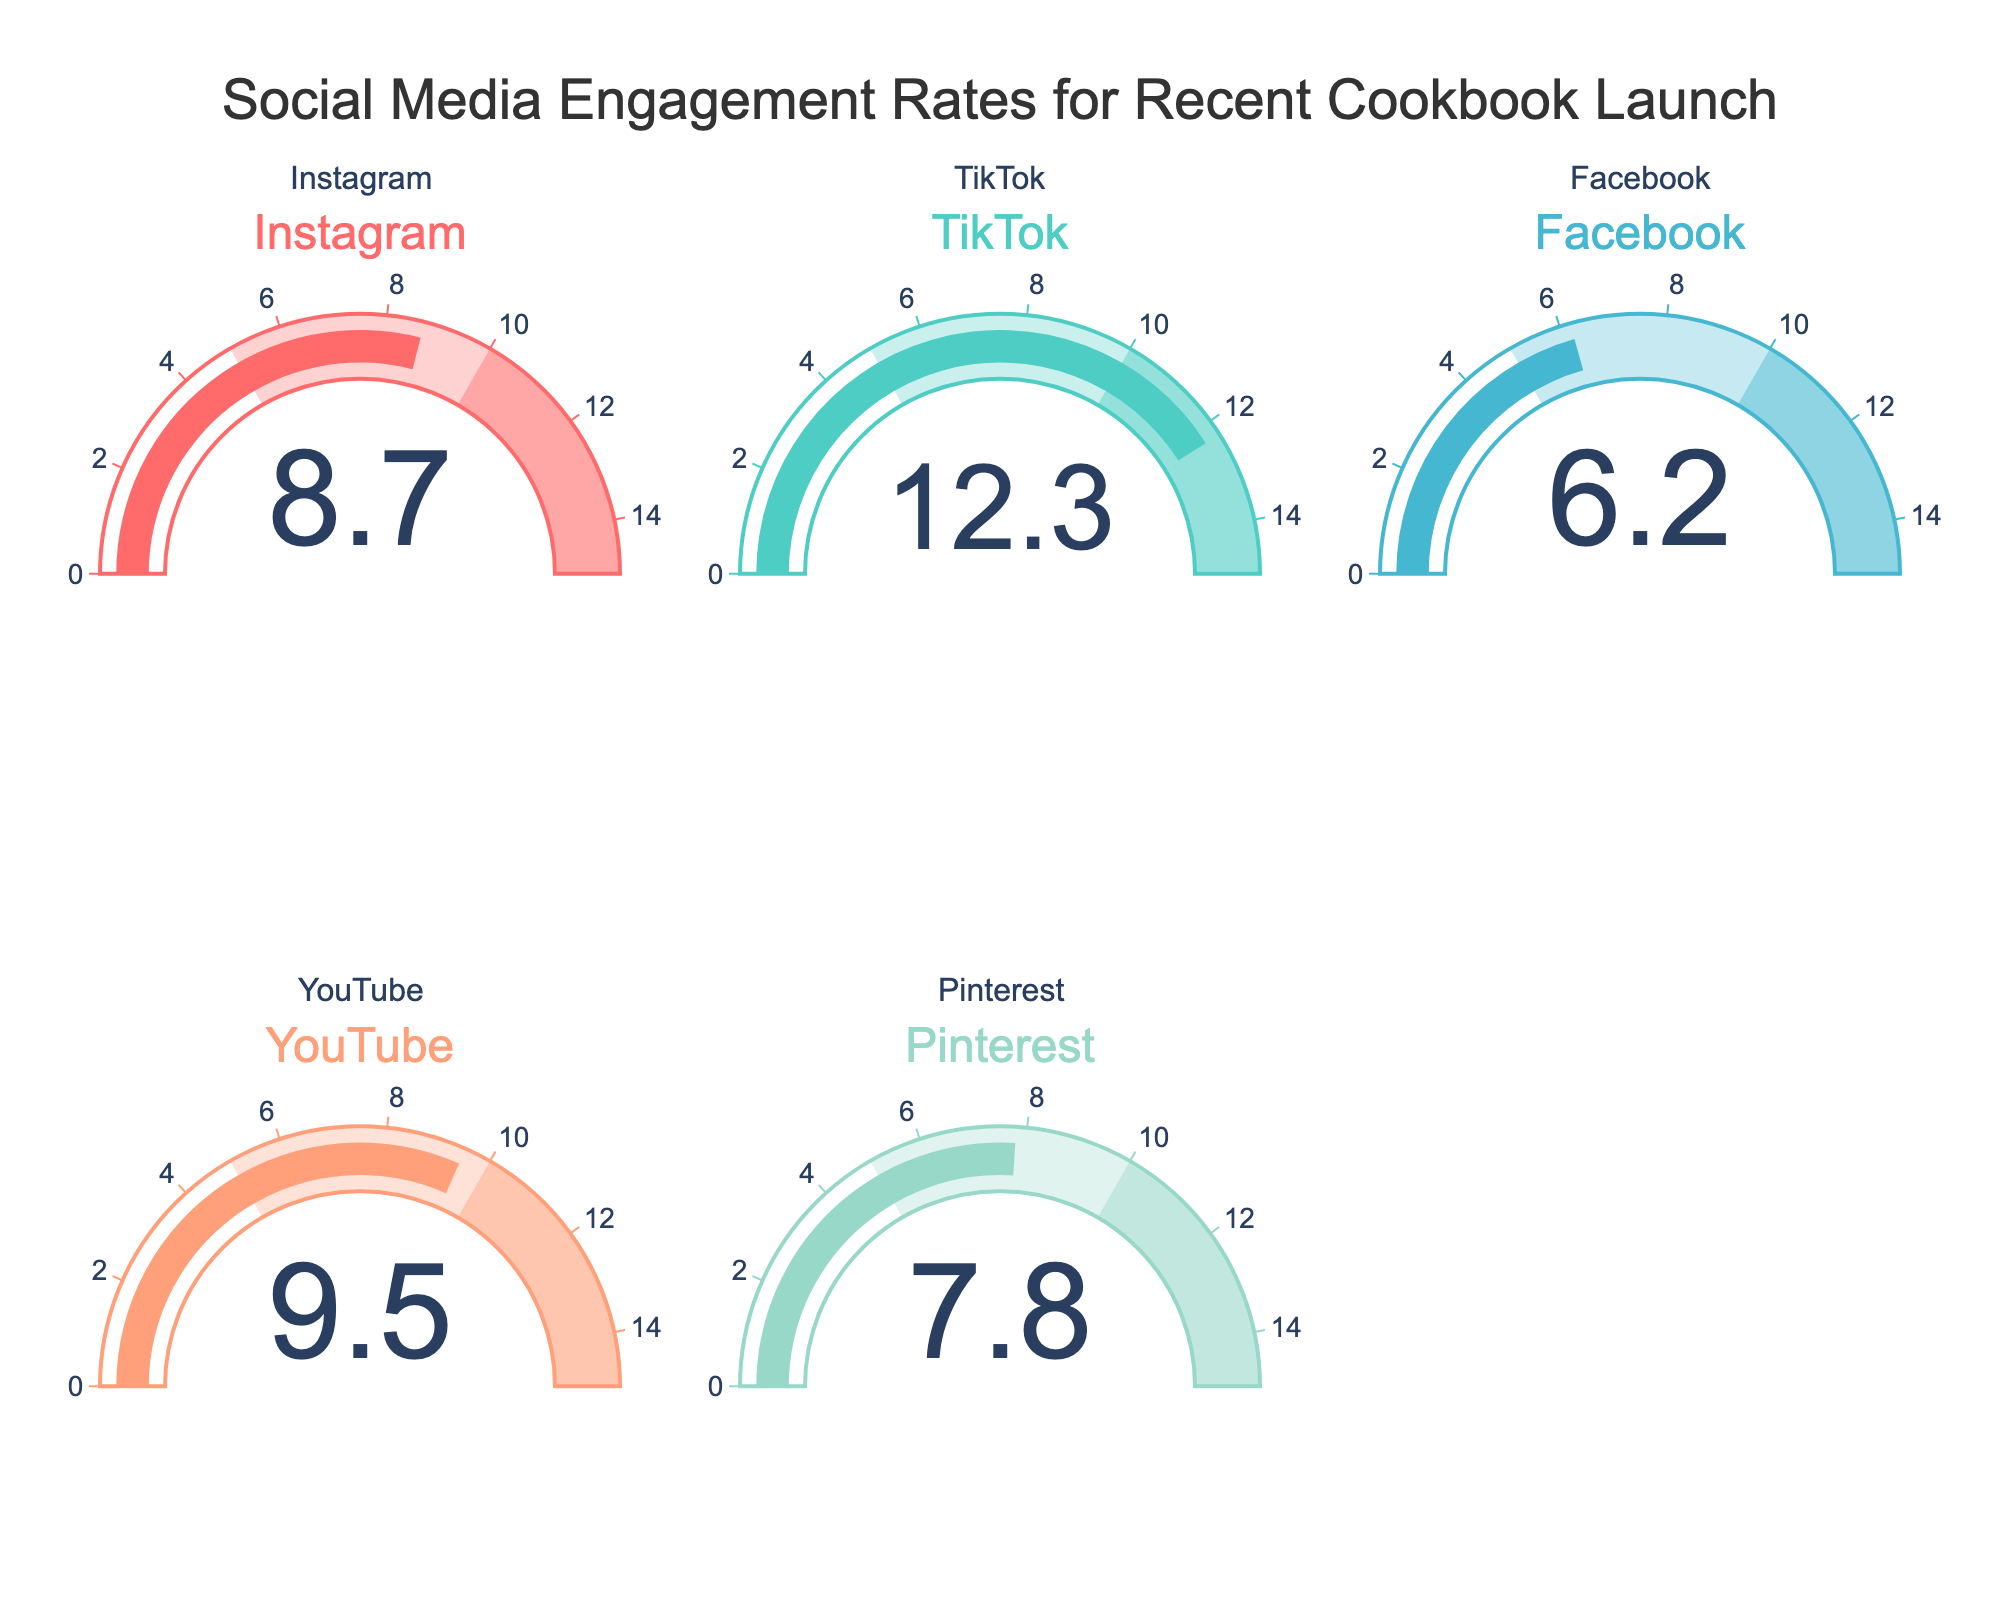How many platforms are represented in the chart? There are six gauge plots, each representing up to five social media platforms. The platforms include Instagram, TikTok, Facebook, YouTube, and Pinterest.
Answer: 5 What is the highest engagement rate shown? By observing the values on the gauges, the highest engagement rate is 12.3%.
Answer: 12.3% Which platform has the lowest engagement rate? The chart shows various engagement rates, and the lowest among them is for Facebook at 6.2%.
Answer: Facebook What is the median engagement rate across all platforms? The engagement rates are 8.7%, 12.3%, 6.2%, 9.5%, and 7.8%. Arranging them in ascending order (6.2%, 7.8%, 8.7%, 9.5%, 12.3%), the middle value or median is 8.7%.
Answer: 8.7% Which platforms have engagement rates greater than 9%? By filtering engagement rates that are higher than 9%, we find Instagram (8.7%), YouTube (9.5%), and TikTok (12.3%) meet this condition.
Answer: TikTok, YouTube Is YouTube engagement rate higher or lower than Pinterest's? The engagement rate for YouTube is 9.5%, while Pinterest's is 7.8%. Since 9.5% is higher than 7.8%, YouTube's rate is higher.
Answer: Higher What is the total engagement rate across all platforms? Summing up the engagement rates of all platforms: 8.7 + 12.3 + 6.2 + 9.5 + 7.8 = 44.5% total.
Answer: 44.5% What is the average engagement rate of TikTok and Instagram? Summing the engagement rates for TikTok (12.3%) and Instagram (8.7%) gives 12.3 + 8.7 = 21. Dividing by 2 results in an average of 10.5%.
Answer: 10.5% What is the difference in engagement rates between TikTok and Facebook? Subtracting Facebook's engagement rate (6.2%) from TikTok's (12.3%) gives 12.3 - 6.2 = 6.1%.
Answer: 6.1% 